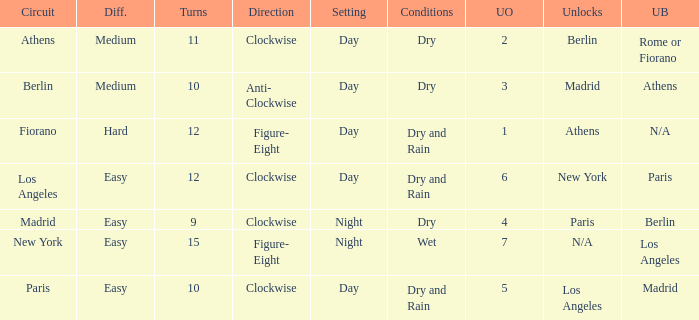What is the lowest unlock order for the athens circuit? 2.0. Could you parse the entire table? {'header': ['Circuit', 'Diff.', 'Turns', 'Direction', 'Setting', 'Conditions', 'UO', 'Unlocks', 'UB'], 'rows': [['Athens', 'Medium', '11', 'Clockwise', 'Day', 'Dry', '2', 'Berlin', 'Rome or Fiorano'], ['Berlin', 'Medium', '10', 'Anti- Clockwise', 'Day', 'Dry', '3', 'Madrid', 'Athens'], ['Fiorano', 'Hard', '12', 'Figure- Eight', 'Day', 'Dry and Rain', '1', 'Athens', 'N/A'], ['Los Angeles', 'Easy', '12', 'Clockwise', 'Day', 'Dry and Rain', '6', 'New York', 'Paris'], ['Madrid', 'Easy', '9', 'Clockwise', 'Night', 'Dry', '4', 'Paris', 'Berlin'], ['New York', 'Easy', '15', 'Figure- Eight', 'Night', 'Wet', '7', 'N/A', 'Los Angeles'], ['Paris', 'Easy', '10', 'Clockwise', 'Day', 'Dry and Rain', '5', 'Los Angeles', 'Madrid']]} 